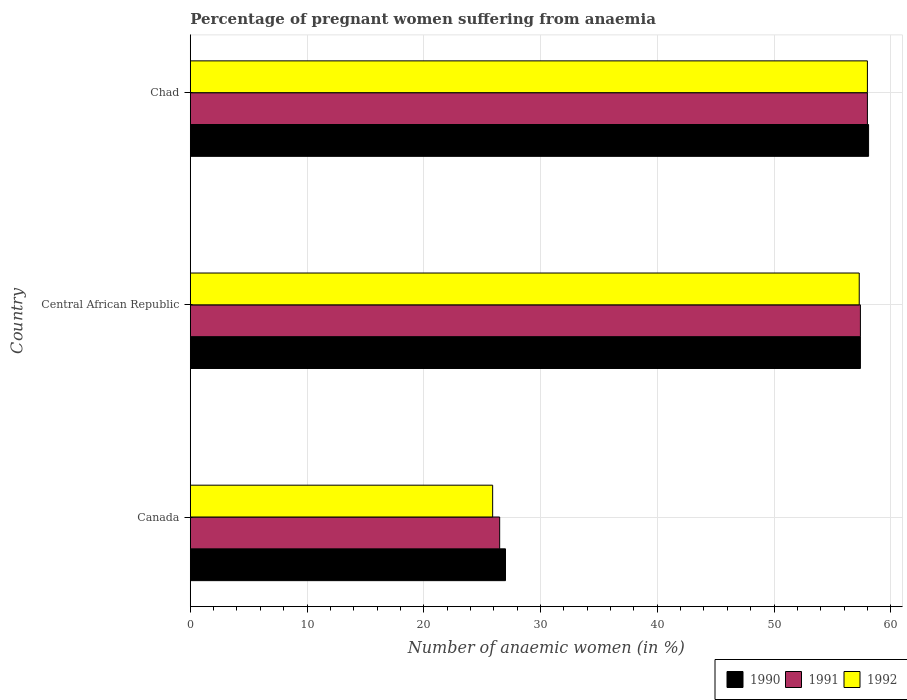How many different coloured bars are there?
Provide a succinct answer. 3. How many bars are there on the 1st tick from the top?
Provide a short and direct response. 3. What is the label of the 1st group of bars from the top?
Provide a succinct answer. Chad. What is the number of anaemic women in 1991 in Chad?
Your answer should be very brief. 58. Across all countries, what is the maximum number of anaemic women in 1991?
Provide a short and direct response. 58. Across all countries, what is the minimum number of anaemic women in 1991?
Give a very brief answer. 26.5. In which country was the number of anaemic women in 1990 maximum?
Offer a very short reply. Chad. In which country was the number of anaemic women in 1991 minimum?
Your response must be concise. Canada. What is the total number of anaemic women in 1990 in the graph?
Give a very brief answer. 142.5. What is the difference between the number of anaemic women in 1992 in Canada and that in Chad?
Your answer should be compact. -32.1. What is the difference between the number of anaemic women in 1990 in Central African Republic and the number of anaemic women in 1992 in Canada?
Make the answer very short. 31.5. What is the average number of anaemic women in 1992 per country?
Give a very brief answer. 47.07. What is the difference between the number of anaemic women in 1991 and number of anaemic women in 1992 in Chad?
Make the answer very short. 0. What is the ratio of the number of anaemic women in 1991 in Canada to that in Central African Republic?
Make the answer very short. 0.46. Is the difference between the number of anaemic women in 1991 in Canada and Chad greater than the difference between the number of anaemic women in 1992 in Canada and Chad?
Your answer should be very brief. Yes. What is the difference between the highest and the second highest number of anaemic women in 1992?
Make the answer very short. 0.7. What is the difference between the highest and the lowest number of anaemic women in 1991?
Keep it short and to the point. 31.5. Is the sum of the number of anaemic women in 1991 in Central African Republic and Chad greater than the maximum number of anaemic women in 1990 across all countries?
Provide a succinct answer. Yes. What does the 2nd bar from the top in Canada represents?
Your answer should be very brief. 1991. Is it the case that in every country, the sum of the number of anaemic women in 1992 and number of anaemic women in 1991 is greater than the number of anaemic women in 1990?
Provide a succinct answer. Yes. How many bars are there?
Provide a succinct answer. 9. Are all the bars in the graph horizontal?
Provide a succinct answer. Yes. What is the difference between two consecutive major ticks on the X-axis?
Your response must be concise. 10. Are the values on the major ticks of X-axis written in scientific E-notation?
Provide a succinct answer. No. Does the graph contain any zero values?
Provide a succinct answer. No. Does the graph contain grids?
Make the answer very short. Yes. Where does the legend appear in the graph?
Your answer should be compact. Bottom right. How many legend labels are there?
Provide a succinct answer. 3. What is the title of the graph?
Provide a short and direct response. Percentage of pregnant women suffering from anaemia. What is the label or title of the X-axis?
Give a very brief answer. Number of anaemic women (in %). What is the Number of anaemic women (in %) of 1991 in Canada?
Your answer should be compact. 26.5. What is the Number of anaemic women (in %) in 1992 in Canada?
Give a very brief answer. 25.9. What is the Number of anaemic women (in %) of 1990 in Central African Republic?
Your response must be concise. 57.4. What is the Number of anaemic women (in %) in 1991 in Central African Republic?
Provide a succinct answer. 57.4. What is the Number of anaemic women (in %) in 1992 in Central African Republic?
Provide a short and direct response. 57.3. What is the Number of anaemic women (in %) in 1990 in Chad?
Ensure brevity in your answer.  58.1. What is the Number of anaemic women (in %) of 1991 in Chad?
Provide a succinct answer. 58. Across all countries, what is the maximum Number of anaemic women (in %) of 1990?
Provide a short and direct response. 58.1. Across all countries, what is the minimum Number of anaemic women (in %) in 1991?
Ensure brevity in your answer.  26.5. Across all countries, what is the minimum Number of anaemic women (in %) of 1992?
Give a very brief answer. 25.9. What is the total Number of anaemic women (in %) in 1990 in the graph?
Provide a succinct answer. 142.5. What is the total Number of anaemic women (in %) in 1991 in the graph?
Your answer should be compact. 141.9. What is the total Number of anaemic women (in %) in 1992 in the graph?
Offer a terse response. 141.2. What is the difference between the Number of anaemic women (in %) of 1990 in Canada and that in Central African Republic?
Make the answer very short. -30.4. What is the difference between the Number of anaemic women (in %) in 1991 in Canada and that in Central African Republic?
Make the answer very short. -30.9. What is the difference between the Number of anaemic women (in %) in 1992 in Canada and that in Central African Republic?
Your answer should be very brief. -31.4. What is the difference between the Number of anaemic women (in %) in 1990 in Canada and that in Chad?
Your answer should be compact. -31.1. What is the difference between the Number of anaemic women (in %) of 1991 in Canada and that in Chad?
Offer a very short reply. -31.5. What is the difference between the Number of anaemic women (in %) of 1992 in Canada and that in Chad?
Offer a terse response. -32.1. What is the difference between the Number of anaemic women (in %) of 1991 in Central African Republic and that in Chad?
Ensure brevity in your answer.  -0.6. What is the difference between the Number of anaemic women (in %) of 1990 in Canada and the Number of anaemic women (in %) of 1991 in Central African Republic?
Ensure brevity in your answer.  -30.4. What is the difference between the Number of anaemic women (in %) in 1990 in Canada and the Number of anaemic women (in %) in 1992 in Central African Republic?
Offer a very short reply. -30.3. What is the difference between the Number of anaemic women (in %) of 1991 in Canada and the Number of anaemic women (in %) of 1992 in Central African Republic?
Make the answer very short. -30.8. What is the difference between the Number of anaemic women (in %) of 1990 in Canada and the Number of anaemic women (in %) of 1991 in Chad?
Your answer should be very brief. -31. What is the difference between the Number of anaemic women (in %) of 1990 in Canada and the Number of anaemic women (in %) of 1992 in Chad?
Your answer should be very brief. -31. What is the difference between the Number of anaemic women (in %) in 1991 in Canada and the Number of anaemic women (in %) in 1992 in Chad?
Make the answer very short. -31.5. What is the difference between the Number of anaemic women (in %) in 1991 in Central African Republic and the Number of anaemic women (in %) in 1992 in Chad?
Make the answer very short. -0.6. What is the average Number of anaemic women (in %) of 1990 per country?
Keep it short and to the point. 47.5. What is the average Number of anaemic women (in %) in 1991 per country?
Your answer should be very brief. 47.3. What is the average Number of anaemic women (in %) in 1992 per country?
Offer a very short reply. 47.07. What is the difference between the Number of anaemic women (in %) of 1990 and Number of anaemic women (in %) of 1991 in Canada?
Your answer should be compact. 0.5. What is the difference between the Number of anaemic women (in %) of 1990 and Number of anaemic women (in %) of 1992 in Canada?
Your answer should be very brief. 1.1. What is the difference between the Number of anaemic women (in %) in 1990 and Number of anaemic women (in %) in 1992 in Central African Republic?
Give a very brief answer. 0.1. What is the difference between the Number of anaemic women (in %) of 1990 and Number of anaemic women (in %) of 1991 in Chad?
Offer a terse response. 0.1. What is the difference between the Number of anaemic women (in %) of 1991 and Number of anaemic women (in %) of 1992 in Chad?
Give a very brief answer. 0. What is the ratio of the Number of anaemic women (in %) of 1990 in Canada to that in Central African Republic?
Make the answer very short. 0.47. What is the ratio of the Number of anaemic women (in %) of 1991 in Canada to that in Central African Republic?
Offer a very short reply. 0.46. What is the ratio of the Number of anaemic women (in %) in 1992 in Canada to that in Central African Republic?
Your answer should be compact. 0.45. What is the ratio of the Number of anaemic women (in %) of 1990 in Canada to that in Chad?
Provide a short and direct response. 0.46. What is the ratio of the Number of anaemic women (in %) in 1991 in Canada to that in Chad?
Make the answer very short. 0.46. What is the ratio of the Number of anaemic women (in %) of 1992 in Canada to that in Chad?
Your response must be concise. 0.45. What is the ratio of the Number of anaemic women (in %) in 1992 in Central African Republic to that in Chad?
Keep it short and to the point. 0.99. What is the difference between the highest and the second highest Number of anaemic women (in %) of 1990?
Give a very brief answer. 0.7. What is the difference between the highest and the lowest Number of anaemic women (in %) in 1990?
Ensure brevity in your answer.  31.1. What is the difference between the highest and the lowest Number of anaemic women (in %) in 1991?
Ensure brevity in your answer.  31.5. What is the difference between the highest and the lowest Number of anaemic women (in %) of 1992?
Your response must be concise. 32.1. 